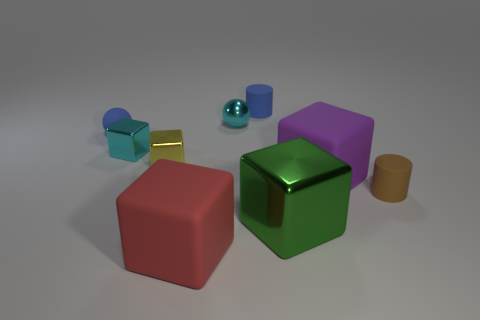How many cyan metallic balls have the same size as the blue sphere?
Your response must be concise. 1. There is another tiny thing that is the same shape as the tiny yellow thing; what is it made of?
Give a very brief answer. Metal. There is a matte cylinder in front of the tiny blue ball; does it have the same color as the tiny metallic object behind the tiny blue rubber ball?
Your answer should be very brief. No. The rubber object in front of the big metallic object has what shape?
Your response must be concise. Cube. The tiny metal ball has what color?
Keep it short and to the point. Cyan. What shape is the small brown thing that is made of the same material as the big red cube?
Provide a succinct answer. Cylinder. There is a matte cylinder that is on the left side of the purple matte cube; is it the same size as the tiny brown cylinder?
Give a very brief answer. Yes. How many objects are tiny blue things to the right of the tiny blue sphere or rubber things that are behind the small blue sphere?
Give a very brief answer. 1. There is a small cylinder in front of the small blue sphere; does it have the same color as the large shiny object?
Provide a succinct answer. No. How many rubber objects are blue things or cyan objects?
Ensure brevity in your answer.  2. 